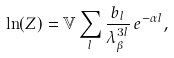Convert formula to latex. <formula><loc_0><loc_0><loc_500><loc_500>\ln ( Z ) = \mathbb { V } \sum _ { l } \frac { b _ { l } } { \lambda _ { \beta } ^ { 3 l } } \, e ^ { - \alpha l } ,</formula> 